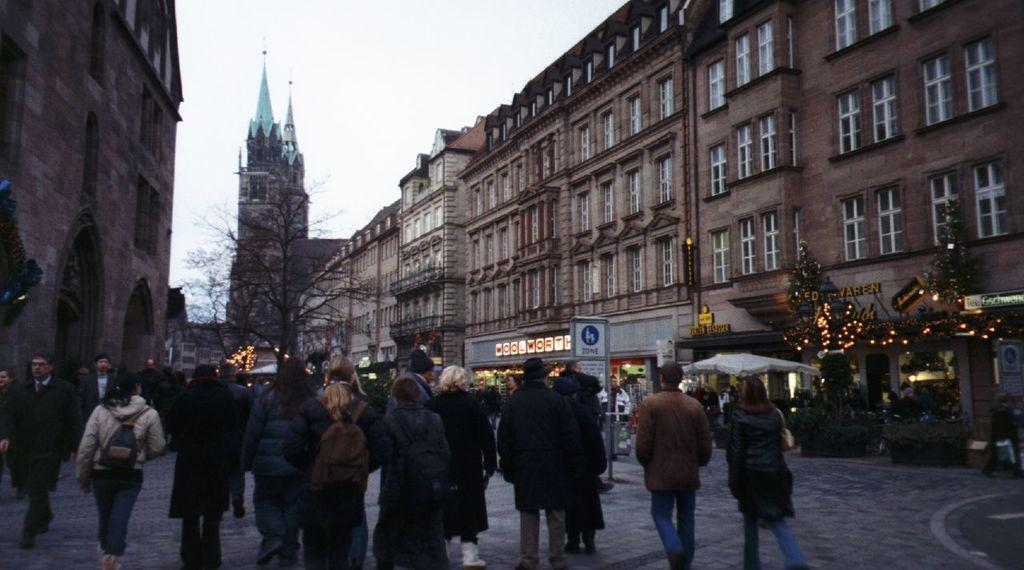What are the people in the image doing? The people in the image are walking on the road. What can be seen besides the people walking on the road? There is a board, tents, lights, trees, stone buildings, and the sky visible in the image. Can you describe the board in the image? Unfortunately, the facts provided do not give enough information to describe the board in detail. What type of structures are visible in the image? There are stone buildings visible in the image. What is visible in the background of the image? The sky is visible in the background of the image. What type of hair can be seen on the donkey in the image? There is no donkey present in the image, so it is not possible to answer that question. What is the minister doing in the image? There is no minister present in the image, so it is not possible to answer that question. 